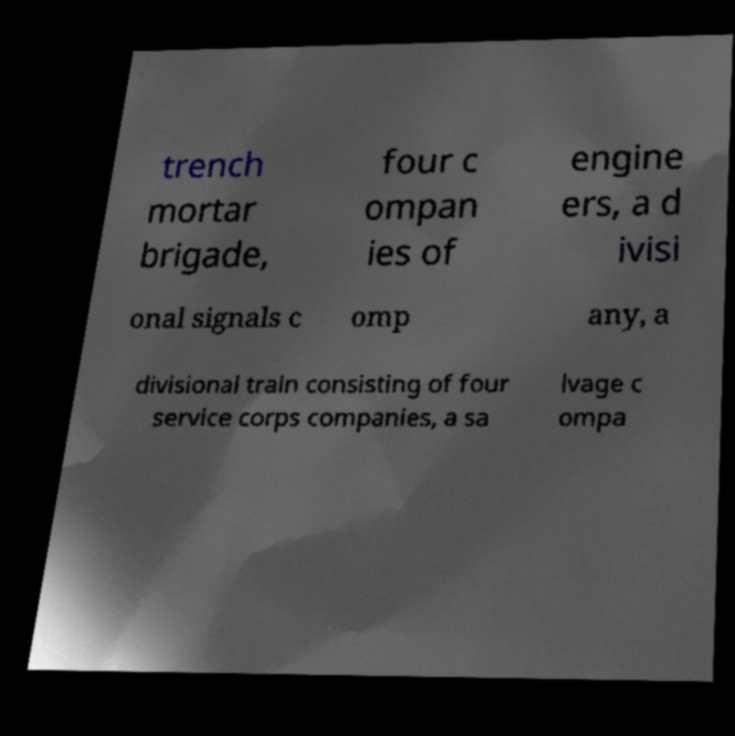Can you read and provide the text displayed in the image?This photo seems to have some interesting text. Can you extract and type it out for me? trench mortar brigade, four c ompan ies of engine ers, a d ivisi onal signals c omp any, a divisional train consisting of four service corps companies, a sa lvage c ompa 